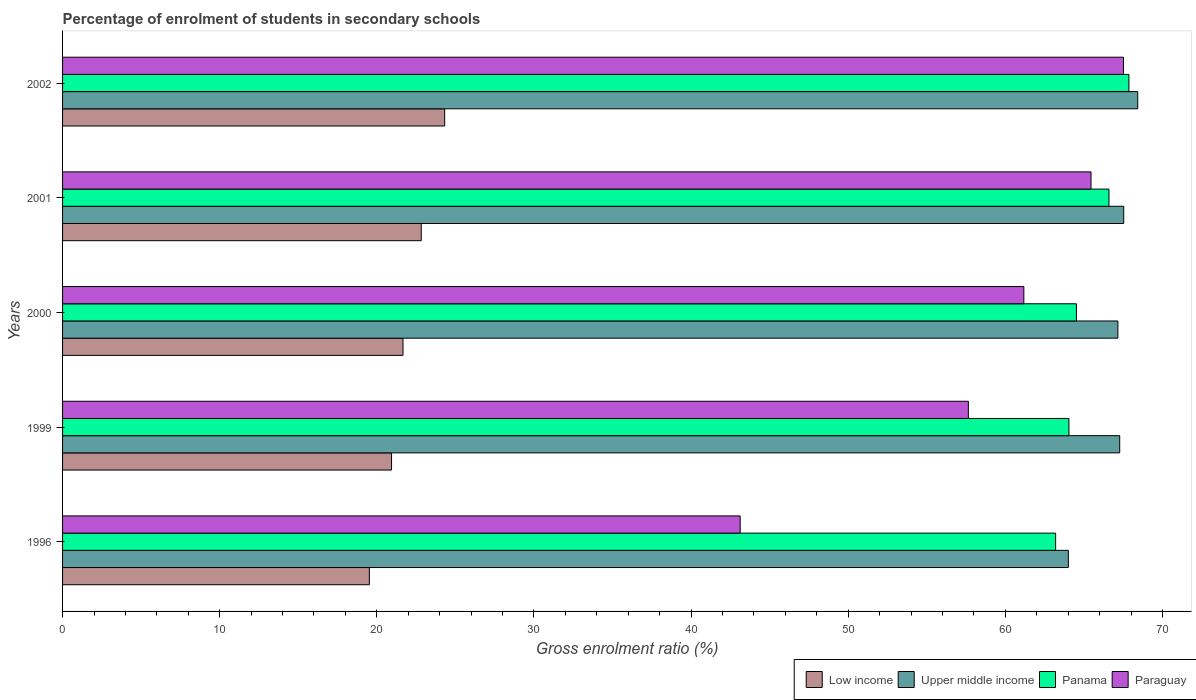How many different coloured bars are there?
Give a very brief answer. 4. Are the number of bars per tick equal to the number of legend labels?
Provide a succinct answer. Yes. How many bars are there on the 1st tick from the top?
Provide a short and direct response. 4. What is the percentage of students enrolled in secondary schools in Paraguay in 2001?
Ensure brevity in your answer.  65.45. Across all years, what is the maximum percentage of students enrolled in secondary schools in Panama?
Offer a terse response. 67.86. Across all years, what is the minimum percentage of students enrolled in secondary schools in Panama?
Offer a very short reply. 63.2. In which year was the percentage of students enrolled in secondary schools in Paraguay maximum?
Your response must be concise. 2002. What is the total percentage of students enrolled in secondary schools in Upper middle income in the graph?
Offer a very short reply. 334.39. What is the difference between the percentage of students enrolled in secondary schools in Upper middle income in 1999 and that in 2001?
Provide a succinct answer. -0.26. What is the difference between the percentage of students enrolled in secondary schools in Low income in 1996 and the percentage of students enrolled in secondary schools in Panama in 2000?
Provide a succinct answer. -45. What is the average percentage of students enrolled in secondary schools in Panama per year?
Your answer should be compact. 65.24. In the year 2001, what is the difference between the percentage of students enrolled in secondary schools in Panama and percentage of students enrolled in secondary schools in Upper middle income?
Make the answer very short. -0.94. In how many years, is the percentage of students enrolled in secondary schools in Paraguay greater than 38 %?
Your answer should be very brief. 5. What is the ratio of the percentage of students enrolled in secondary schools in Low income in 1999 to that in 2001?
Keep it short and to the point. 0.92. Is the difference between the percentage of students enrolled in secondary schools in Panama in 2001 and 2002 greater than the difference between the percentage of students enrolled in secondary schools in Upper middle income in 2001 and 2002?
Your answer should be very brief. No. What is the difference between the highest and the second highest percentage of students enrolled in secondary schools in Paraguay?
Provide a succinct answer. 2.07. What is the difference between the highest and the lowest percentage of students enrolled in secondary schools in Paraguay?
Your response must be concise. 24.39. In how many years, is the percentage of students enrolled in secondary schools in Panama greater than the average percentage of students enrolled in secondary schools in Panama taken over all years?
Ensure brevity in your answer.  2. Is the sum of the percentage of students enrolled in secondary schools in Panama in 1996 and 2002 greater than the maximum percentage of students enrolled in secondary schools in Paraguay across all years?
Offer a very short reply. Yes. What does the 2nd bar from the top in 2001 represents?
Provide a succinct answer. Panama. How many bars are there?
Offer a terse response. 20. How many years are there in the graph?
Provide a short and direct response. 5. What is the difference between two consecutive major ticks on the X-axis?
Keep it short and to the point. 10. Does the graph contain grids?
Make the answer very short. No. How many legend labels are there?
Your answer should be compact. 4. How are the legend labels stacked?
Your response must be concise. Horizontal. What is the title of the graph?
Your response must be concise. Percentage of enrolment of students in secondary schools. What is the label or title of the Y-axis?
Make the answer very short. Years. What is the Gross enrolment ratio (%) of Low income in 1996?
Offer a terse response. 19.52. What is the Gross enrolment ratio (%) in Upper middle income in 1996?
Offer a terse response. 64.01. What is the Gross enrolment ratio (%) in Panama in 1996?
Provide a short and direct response. 63.2. What is the Gross enrolment ratio (%) in Paraguay in 1996?
Provide a succinct answer. 43.12. What is the Gross enrolment ratio (%) of Low income in 1999?
Ensure brevity in your answer.  20.94. What is the Gross enrolment ratio (%) of Upper middle income in 1999?
Offer a terse response. 67.27. What is the Gross enrolment ratio (%) of Panama in 1999?
Offer a terse response. 64.04. What is the Gross enrolment ratio (%) of Paraguay in 1999?
Ensure brevity in your answer.  57.64. What is the Gross enrolment ratio (%) in Low income in 2000?
Offer a very short reply. 21.66. What is the Gross enrolment ratio (%) in Upper middle income in 2000?
Offer a terse response. 67.16. What is the Gross enrolment ratio (%) in Panama in 2000?
Offer a terse response. 64.52. What is the Gross enrolment ratio (%) of Paraguay in 2000?
Your answer should be very brief. 61.17. What is the Gross enrolment ratio (%) of Low income in 2001?
Your answer should be very brief. 22.83. What is the Gross enrolment ratio (%) of Upper middle income in 2001?
Your response must be concise. 67.53. What is the Gross enrolment ratio (%) in Panama in 2001?
Provide a succinct answer. 66.59. What is the Gross enrolment ratio (%) of Paraguay in 2001?
Provide a succinct answer. 65.45. What is the Gross enrolment ratio (%) in Low income in 2002?
Your answer should be compact. 24.32. What is the Gross enrolment ratio (%) of Upper middle income in 2002?
Keep it short and to the point. 68.42. What is the Gross enrolment ratio (%) of Panama in 2002?
Offer a terse response. 67.86. What is the Gross enrolment ratio (%) in Paraguay in 2002?
Keep it short and to the point. 67.51. Across all years, what is the maximum Gross enrolment ratio (%) of Low income?
Ensure brevity in your answer.  24.32. Across all years, what is the maximum Gross enrolment ratio (%) in Upper middle income?
Provide a short and direct response. 68.42. Across all years, what is the maximum Gross enrolment ratio (%) in Panama?
Keep it short and to the point. 67.86. Across all years, what is the maximum Gross enrolment ratio (%) in Paraguay?
Provide a short and direct response. 67.51. Across all years, what is the minimum Gross enrolment ratio (%) in Low income?
Your answer should be compact. 19.52. Across all years, what is the minimum Gross enrolment ratio (%) of Upper middle income?
Your answer should be compact. 64.01. Across all years, what is the minimum Gross enrolment ratio (%) in Panama?
Give a very brief answer. 63.2. Across all years, what is the minimum Gross enrolment ratio (%) in Paraguay?
Provide a succinct answer. 43.12. What is the total Gross enrolment ratio (%) in Low income in the graph?
Keep it short and to the point. 109.27. What is the total Gross enrolment ratio (%) of Upper middle income in the graph?
Provide a succinct answer. 334.39. What is the total Gross enrolment ratio (%) in Panama in the graph?
Offer a very short reply. 326.21. What is the total Gross enrolment ratio (%) of Paraguay in the graph?
Your response must be concise. 294.9. What is the difference between the Gross enrolment ratio (%) of Low income in 1996 and that in 1999?
Ensure brevity in your answer.  -1.41. What is the difference between the Gross enrolment ratio (%) in Upper middle income in 1996 and that in 1999?
Make the answer very short. -3.27. What is the difference between the Gross enrolment ratio (%) in Panama in 1996 and that in 1999?
Make the answer very short. -0.85. What is the difference between the Gross enrolment ratio (%) of Paraguay in 1996 and that in 1999?
Offer a terse response. -14.52. What is the difference between the Gross enrolment ratio (%) in Low income in 1996 and that in 2000?
Provide a succinct answer. -2.14. What is the difference between the Gross enrolment ratio (%) in Upper middle income in 1996 and that in 2000?
Give a very brief answer. -3.15. What is the difference between the Gross enrolment ratio (%) in Panama in 1996 and that in 2000?
Provide a succinct answer. -1.33. What is the difference between the Gross enrolment ratio (%) of Paraguay in 1996 and that in 2000?
Provide a succinct answer. -18.05. What is the difference between the Gross enrolment ratio (%) of Low income in 1996 and that in 2001?
Provide a succinct answer. -3.3. What is the difference between the Gross enrolment ratio (%) of Upper middle income in 1996 and that in 2001?
Offer a terse response. -3.52. What is the difference between the Gross enrolment ratio (%) in Panama in 1996 and that in 2001?
Make the answer very short. -3.39. What is the difference between the Gross enrolment ratio (%) in Paraguay in 1996 and that in 2001?
Your response must be concise. -22.33. What is the difference between the Gross enrolment ratio (%) in Low income in 1996 and that in 2002?
Your answer should be compact. -4.79. What is the difference between the Gross enrolment ratio (%) in Upper middle income in 1996 and that in 2002?
Provide a succinct answer. -4.41. What is the difference between the Gross enrolment ratio (%) of Panama in 1996 and that in 2002?
Offer a very short reply. -4.66. What is the difference between the Gross enrolment ratio (%) in Paraguay in 1996 and that in 2002?
Offer a terse response. -24.39. What is the difference between the Gross enrolment ratio (%) in Low income in 1999 and that in 2000?
Provide a succinct answer. -0.73. What is the difference between the Gross enrolment ratio (%) of Upper middle income in 1999 and that in 2000?
Ensure brevity in your answer.  0.12. What is the difference between the Gross enrolment ratio (%) of Panama in 1999 and that in 2000?
Provide a succinct answer. -0.48. What is the difference between the Gross enrolment ratio (%) in Paraguay in 1999 and that in 2000?
Your answer should be compact. -3.53. What is the difference between the Gross enrolment ratio (%) of Low income in 1999 and that in 2001?
Offer a very short reply. -1.89. What is the difference between the Gross enrolment ratio (%) in Upper middle income in 1999 and that in 2001?
Make the answer very short. -0.26. What is the difference between the Gross enrolment ratio (%) of Panama in 1999 and that in 2001?
Offer a terse response. -2.55. What is the difference between the Gross enrolment ratio (%) in Paraguay in 1999 and that in 2001?
Provide a short and direct response. -7.81. What is the difference between the Gross enrolment ratio (%) of Low income in 1999 and that in 2002?
Your response must be concise. -3.38. What is the difference between the Gross enrolment ratio (%) in Upper middle income in 1999 and that in 2002?
Your answer should be compact. -1.15. What is the difference between the Gross enrolment ratio (%) in Panama in 1999 and that in 2002?
Your response must be concise. -3.82. What is the difference between the Gross enrolment ratio (%) of Paraguay in 1999 and that in 2002?
Your answer should be very brief. -9.87. What is the difference between the Gross enrolment ratio (%) of Low income in 2000 and that in 2001?
Give a very brief answer. -1.16. What is the difference between the Gross enrolment ratio (%) of Upper middle income in 2000 and that in 2001?
Offer a terse response. -0.37. What is the difference between the Gross enrolment ratio (%) in Panama in 2000 and that in 2001?
Provide a short and direct response. -2.07. What is the difference between the Gross enrolment ratio (%) in Paraguay in 2000 and that in 2001?
Make the answer very short. -4.28. What is the difference between the Gross enrolment ratio (%) in Low income in 2000 and that in 2002?
Make the answer very short. -2.65. What is the difference between the Gross enrolment ratio (%) of Upper middle income in 2000 and that in 2002?
Offer a very short reply. -1.26. What is the difference between the Gross enrolment ratio (%) in Panama in 2000 and that in 2002?
Provide a succinct answer. -3.34. What is the difference between the Gross enrolment ratio (%) of Paraguay in 2000 and that in 2002?
Keep it short and to the point. -6.34. What is the difference between the Gross enrolment ratio (%) of Low income in 2001 and that in 2002?
Make the answer very short. -1.49. What is the difference between the Gross enrolment ratio (%) in Upper middle income in 2001 and that in 2002?
Provide a short and direct response. -0.89. What is the difference between the Gross enrolment ratio (%) in Panama in 2001 and that in 2002?
Your response must be concise. -1.27. What is the difference between the Gross enrolment ratio (%) in Paraguay in 2001 and that in 2002?
Your answer should be very brief. -2.07. What is the difference between the Gross enrolment ratio (%) of Low income in 1996 and the Gross enrolment ratio (%) of Upper middle income in 1999?
Keep it short and to the point. -47.75. What is the difference between the Gross enrolment ratio (%) in Low income in 1996 and the Gross enrolment ratio (%) in Panama in 1999?
Make the answer very short. -44.52. What is the difference between the Gross enrolment ratio (%) in Low income in 1996 and the Gross enrolment ratio (%) in Paraguay in 1999?
Your answer should be compact. -38.12. What is the difference between the Gross enrolment ratio (%) of Upper middle income in 1996 and the Gross enrolment ratio (%) of Panama in 1999?
Your answer should be very brief. -0.04. What is the difference between the Gross enrolment ratio (%) of Upper middle income in 1996 and the Gross enrolment ratio (%) of Paraguay in 1999?
Ensure brevity in your answer.  6.36. What is the difference between the Gross enrolment ratio (%) in Panama in 1996 and the Gross enrolment ratio (%) in Paraguay in 1999?
Your answer should be compact. 5.55. What is the difference between the Gross enrolment ratio (%) in Low income in 1996 and the Gross enrolment ratio (%) in Upper middle income in 2000?
Provide a short and direct response. -47.64. What is the difference between the Gross enrolment ratio (%) of Low income in 1996 and the Gross enrolment ratio (%) of Panama in 2000?
Ensure brevity in your answer.  -45. What is the difference between the Gross enrolment ratio (%) of Low income in 1996 and the Gross enrolment ratio (%) of Paraguay in 2000?
Your answer should be compact. -41.65. What is the difference between the Gross enrolment ratio (%) of Upper middle income in 1996 and the Gross enrolment ratio (%) of Panama in 2000?
Provide a succinct answer. -0.52. What is the difference between the Gross enrolment ratio (%) of Upper middle income in 1996 and the Gross enrolment ratio (%) of Paraguay in 2000?
Your answer should be very brief. 2.83. What is the difference between the Gross enrolment ratio (%) of Panama in 1996 and the Gross enrolment ratio (%) of Paraguay in 2000?
Make the answer very short. 2.02. What is the difference between the Gross enrolment ratio (%) in Low income in 1996 and the Gross enrolment ratio (%) in Upper middle income in 2001?
Keep it short and to the point. -48.01. What is the difference between the Gross enrolment ratio (%) in Low income in 1996 and the Gross enrolment ratio (%) in Panama in 2001?
Provide a succinct answer. -47.07. What is the difference between the Gross enrolment ratio (%) in Low income in 1996 and the Gross enrolment ratio (%) in Paraguay in 2001?
Offer a very short reply. -45.93. What is the difference between the Gross enrolment ratio (%) of Upper middle income in 1996 and the Gross enrolment ratio (%) of Panama in 2001?
Your answer should be compact. -2.58. What is the difference between the Gross enrolment ratio (%) of Upper middle income in 1996 and the Gross enrolment ratio (%) of Paraguay in 2001?
Give a very brief answer. -1.44. What is the difference between the Gross enrolment ratio (%) in Panama in 1996 and the Gross enrolment ratio (%) in Paraguay in 2001?
Offer a very short reply. -2.25. What is the difference between the Gross enrolment ratio (%) in Low income in 1996 and the Gross enrolment ratio (%) in Upper middle income in 2002?
Your answer should be compact. -48.9. What is the difference between the Gross enrolment ratio (%) of Low income in 1996 and the Gross enrolment ratio (%) of Panama in 2002?
Your answer should be very brief. -48.34. What is the difference between the Gross enrolment ratio (%) in Low income in 1996 and the Gross enrolment ratio (%) in Paraguay in 2002?
Give a very brief answer. -47.99. What is the difference between the Gross enrolment ratio (%) of Upper middle income in 1996 and the Gross enrolment ratio (%) of Panama in 2002?
Make the answer very short. -3.85. What is the difference between the Gross enrolment ratio (%) in Upper middle income in 1996 and the Gross enrolment ratio (%) in Paraguay in 2002?
Give a very brief answer. -3.51. What is the difference between the Gross enrolment ratio (%) of Panama in 1996 and the Gross enrolment ratio (%) of Paraguay in 2002?
Keep it short and to the point. -4.32. What is the difference between the Gross enrolment ratio (%) in Low income in 1999 and the Gross enrolment ratio (%) in Upper middle income in 2000?
Ensure brevity in your answer.  -46.22. What is the difference between the Gross enrolment ratio (%) of Low income in 1999 and the Gross enrolment ratio (%) of Panama in 2000?
Provide a succinct answer. -43.59. What is the difference between the Gross enrolment ratio (%) in Low income in 1999 and the Gross enrolment ratio (%) in Paraguay in 2000?
Offer a very short reply. -40.24. What is the difference between the Gross enrolment ratio (%) of Upper middle income in 1999 and the Gross enrolment ratio (%) of Panama in 2000?
Your answer should be compact. 2.75. What is the difference between the Gross enrolment ratio (%) of Upper middle income in 1999 and the Gross enrolment ratio (%) of Paraguay in 2000?
Your answer should be very brief. 6.1. What is the difference between the Gross enrolment ratio (%) of Panama in 1999 and the Gross enrolment ratio (%) of Paraguay in 2000?
Give a very brief answer. 2.87. What is the difference between the Gross enrolment ratio (%) in Low income in 1999 and the Gross enrolment ratio (%) in Upper middle income in 2001?
Ensure brevity in your answer.  -46.59. What is the difference between the Gross enrolment ratio (%) in Low income in 1999 and the Gross enrolment ratio (%) in Panama in 2001?
Provide a short and direct response. -45.65. What is the difference between the Gross enrolment ratio (%) in Low income in 1999 and the Gross enrolment ratio (%) in Paraguay in 2001?
Make the answer very short. -44.51. What is the difference between the Gross enrolment ratio (%) in Upper middle income in 1999 and the Gross enrolment ratio (%) in Panama in 2001?
Make the answer very short. 0.68. What is the difference between the Gross enrolment ratio (%) in Upper middle income in 1999 and the Gross enrolment ratio (%) in Paraguay in 2001?
Your response must be concise. 1.83. What is the difference between the Gross enrolment ratio (%) of Panama in 1999 and the Gross enrolment ratio (%) of Paraguay in 2001?
Give a very brief answer. -1.41. What is the difference between the Gross enrolment ratio (%) of Low income in 1999 and the Gross enrolment ratio (%) of Upper middle income in 2002?
Make the answer very short. -47.49. What is the difference between the Gross enrolment ratio (%) in Low income in 1999 and the Gross enrolment ratio (%) in Panama in 2002?
Offer a very short reply. -46.92. What is the difference between the Gross enrolment ratio (%) of Low income in 1999 and the Gross enrolment ratio (%) of Paraguay in 2002?
Offer a very short reply. -46.58. What is the difference between the Gross enrolment ratio (%) of Upper middle income in 1999 and the Gross enrolment ratio (%) of Panama in 2002?
Offer a terse response. -0.59. What is the difference between the Gross enrolment ratio (%) of Upper middle income in 1999 and the Gross enrolment ratio (%) of Paraguay in 2002?
Your response must be concise. -0.24. What is the difference between the Gross enrolment ratio (%) of Panama in 1999 and the Gross enrolment ratio (%) of Paraguay in 2002?
Ensure brevity in your answer.  -3.47. What is the difference between the Gross enrolment ratio (%) in Low income in 2000 and the Gross enrolment ratio (%) in Upper middle income in 2001?
Keep it short and to the point. -45.87. What is the difference between the Gross enrolment ratio (%) of Low income in 2000 and the Gross enrolment ratio (%) of Panama in 2001?
Your answer should be very brief. -44.93. What is the difference between the Gross enrolment ratio (%) in Low income in 2000 and the Gross enrolment ratio (%) in Paraguay in 2001?
Give a very brief answer. -43.78. What is the difference between the Gross enrolment ratio (%) in Upper middle income in 2000 and the Gross enrolment ratio (%) in Panama in 2001?
Provide a short and direct response. 0.57. What is the difference between the Gross enrolment ratio (%) of Upper middle income in 2000 and the Gross enrolment ratio (%) of Paraguay in 2001?
Your answer should be compact. 1.71. What is the difference between the Gross enrolment ratio (%) of Panama in 2000 and the Gross enrolment ratio (%) of Paraguay in 2001?
Offer a terse response. -0.93. What is the difference between the Gross enrolment ratio (%) of Low income in 2000 and the Gross enrolment ratio (%) of Upper middle income in 2002?
Ensure brevity in your answer.  -46.76. What is the difference between the Gross enrolment ratio (%) of Low income in 2000 and the Gross enrolment ratio (%) of Panama in 2002?
Keep it short and to the point. -46.2. What is the difference between the Gross enrolment ratio (%) in Low income in 2000 and the Gross enrolment ratio (%) in Paraguay in 2002?
Provide a succinct answer. -45.85. What is the difference between the Gross enrolment ratio (%) in Upper middle income in 2000 and the Gross enrolment ratio (%) in Panama in 2002?
Offer a terse response. -0.7. What is the difference between the Gross enrolment ratio (%) in Upper middle income in 2000 and the Gross enrolment ratio (%) in Paraguay in 2002?
Give a very brief answer. -0.36. What is the difference between the Gross enrolment ratio (%) in Panama in 2000 and the Gross enrolment ratio (%) in Paraguay in 2002?
Your answer should be very brief. -2.99. What is the difference between the Gross enrolment ratio (%) of Low income in 2001 and the Gross enrolment ratio (%) of Upper middle income in 2002?
Make the answer very short. -45.6. What is the difference between the Gross enrolment ratio (%) in Low income in 2001 and the Gross enrolment ratio (%) in Panama in 2002?
Keep it short and to the point. -45.03. What is the difference between the Gross enrolment ratio (%) in Low income in 2001 and the Gross enrolment ratio (%) in Paraguay in 2002?
Your answer should be compact. -44.69. What is the difference between the Gross enrolment ratio (%) of Upper middle income in 2001 and the Gross enrolment ratio (%) of Panama in 2002?
Provide a succinct answer. -0.33. What is the difference between the Gross enrolment ratio (%) of Upper middle income in 2001 and the Gross enrolment ratio (%) of Paraguay in 2002?
Make the answer very short. 0.02. What is the difference between the Gross enrolment ratio (%) of Panama in 2001 and the Gross enrolment ratio (%) of Paraguay in 2002?
Your response must be concise. -0.92. What is the average Gross enrolment ratio (%) of Low income per year?
Offer a terse response. 21.85. What is the average Gross enrolment ratio (%) in Upper middle income per year?
Ensure brevity in your answer.  66.88. What is the average Gross enrolment ratio (%) in Panama per year?
Your response must be concise. 65.24. What is the average Gross enrolment ratio (%) of Paraguay per year?
Provide a short and direct response. 58.98. In the year 1996, what is the difference between the Gross enrolment ratio (%) in Low income and Gross enrolment ratio (%) in Upper middle income?
Provide a short and direct response. -44.48. In the year 1996, what is the difference between the Gross enrolment ratio (%) of Low income and Gross enrolment ratio (%) of Panama?
Offer a very short reply. -43.67. In the year 1996, what is the difference between the Gross enrolment ratio (%) in Low income and Gross enrolment ratio (%) in Paraguay?
Provide a succinct answer. -23.6. In the year 1996, what is the difference between the Gross enrolment ratio (%) in Upper middle income and Gross enrolment ratio (%) in Panama?
Give a very brief answer. 0.81. In the year 1996, what is the difference between the Gross enrolment ratio (%) in Upper middle income and Gross enrolment ratio (%) in Paraguay?
Give a very brief answer. 20.89. In the year 1996, what is the difference between the Gross enrolment ratio (%) of Panama and Gross enrolment ratio (%) of Paraguay?
Your answer should be compact. 20.07. In the year 1999, what is the difference between the Gross enrolment ratio (%) in Low income and Gross enrolment ratio (%) in Upper middle income?
Your answer should be very brief. -46.34. In the year 1999, what is the difference between the Gross enrolment ratio (%) in Low income and Gross enrolment ratio (%) in Panama?
Offer a terse response. -43.11. In the year 1999, what is the difference between the Gross enrolment ratio (%) of Low income and Gross enrolment ratio (%) of Paraguay?
Give a very brief answer. -36.71. In the year 1999, what is the difference between the Gross enrolment ratio (%) of Upper middle income and Gross enrolment ratio (%) of Panama?
Give a very brief answer. 3.23. In the year 1999, what is the difference between the Gross enrolment ratio (%) in Upper middle income and Gross enrolment ratio (%) in Paraguay?
Ensure brevity in your answer.  9.63. In the year 1999, what is the difference between the Gross enrolment ratio (%) of Panama and Gross enrolment ratio (%) of Paraguay?
Provide a succinct answer. 6.4. In the year 2000, what is the difference between the Gross enrolment ratio (%) of Low income and Gross enrolment ratio (%) of Upper middle income?
Keep it short and to the point. -45.49. In the year 2000, what is the difference between the Gross enrolment ratio (%) of Low income and Gross enrolment ratio (%) of Panama?
Your response must be concise. -42.86. In the year 2000, what is the difference between the Gross enrolment ratio (%) of Low income and Gross enrolment ratio (%) of Paraguay?
Keep it short and to the point. -39.51. In the year 2000, what is the difference between the Gross enrolment ratio (%) in Upper middle income and Gross enrolment ratio (%) in Panama?
Ensure brevity in your answer.  2.64. In the year 2000, what is the difference between the Gross enrolment ratio (%) in Upper middle income and Gross enrolment ratio (%) in Paraguay?
Ensure brevity in your answer.  5.98. In the year 2000, what is the difference between the Gross enrolment ratio (%) in Panama and Gross enrolment ratio (%) in Paraguay?
Make the answer very short. 3.35. In the year 2001, what is the difference between the Gross enrolment ratio (%) of Low income and Gross enrolment ratio (%) of Upper middle income?
Your answer should be very brief. -44.7. In the year 2001, what is the difference between the Gross enrolment ratio (%) of Low income and Gross enrolment ratio (%) of Panama?
Make the answer very short. -43.76. In the year 2001, what is the difference between the Gross enrolment ratio (%) in Low income and Gross enrolment ratio (%) in Paraguay?
Make the answer very short. -42.62. In the year 2001, what is the difference between the Gross enrolment ratio (%) in Upper middle income and Gross enrolment ratio (%) in Panama?
Ensure brevity in your answer.  0.94. In the year 2001, what is the difference between the Gross enrolment ratio (%) in Upper middle income and Gross enrolment ratio (%) in Paraguay?
Your response must be concise. 2.08. In the year 2001, what is the difference between the Gross enrolment ratio (%) in Panama and Gross enrolment ratio (%) in Paraguay?
Ensure brevity in your answer.  1.14. In the year 2002, what is the difference between the Gross enrolment ratio (%) in Low income and Gross enrolment ratio (%) in Upper middle income?
Keep it short and to the point. -44.11. In the year 2002, what is the difference between the Gross enrolment ratio (%) in Low income and Gross enrolment ratio (%) in Panama?
Your answer should be very brief. -43.54. In the year 2002, what is the difference between the Gross enrolment ratio (%) in Low income and Gross enrolment ratio (%) in Paraguay?
Offer a very short reply. -43.2. In the year 2002, what is the difference between the Gross enrolment ratio (%) in Upper middle income and Gross enrolment ratio (%) in Panama?
Your answer should be compact. 0.56. In the year 2002, what is the difference between the Gross enrolment ratio (%) in Upper middle income and Gross enrolment ratio (%) in Paraguay?
Provide a succinct answer. 0.91. In the year 2002, what is the difference between the Gross enrolment ratio (%) of Panama and Gross enrolment ratio (%) of Paraguay?
Provide a succinct answer. 0.35. What is the ratio of the Gross enrolment ratio (%) in Low income in 1996 to that in 1999?
Ensure brevity in your answer.  0.93. What is the ratio of the Gross enrolment ratio (%) in Upper middle income in 1996 to that in 1999?
Provide a succinct answer. 0.95. What is the ratio of the Gross enrolment ratio (%) of Panama in 1996 to that in 1999?
Your answer should be compact. 0.99. What is the ratio of the Gross enrolment ratio (%) in Paraguay in 1996 to that in 1999?
Offer a terse response. 0.75. What is the ratio of the Gross enrolment ratio (%) in Low income in 1996 to that in 2000?
Provide a short and direct response. 0.9. What is the ratio of the Gross enrolment ratio (%) of Upper middle income in 1996 to that in 2000?
Your answer should be compact. 0.95. What is the ratio of the Gross enrolment ratio (%) of Panama in 1996 to that in 2000?
Give a very brief answer. 0.98. What is the ratio of the Gross enrolment ratio (%) of Paraguay in 1996 to that in 2000?
Provide a succinct answer. 0.7. What is the ratio of the Gross enrolment ratio (%) in Low income in 1996 to that in 2001?
Your answer should be very brief. 0.86. What is the ratio of the Gross enrolment ratio (%) in Upper middle income in 1996 to that in 2001?
Your response must be concise. 0.95. What is the ratio of the Gross enrolment ratio (%) in Panama in 1996 to that in 2001?
Ensure brevity in your answer.  0.95. What is the ratio of the Gross enrolment ratio (%) of Paraguay in 1996 to that in 2001?
Give a very brief answer. 0.66. What is the ratio of the Gross enrolment ratio (%) of Low income in 1996 to that in 2002?
Ensure brevity in your answer.  0.8. What is the ratio of the Gross enrolment ratio (%) in Upper middle income in 1996 to that in 2002?
Your answer should be very brief. 0.94. What is the ratio of the Gross enrolment ratio (%) of Panama in 1996 to that in 2002?
Your answer should be compact. 0.93. What is the ratio of the Gross enrolment ratio (%) in Paraguay in 1996 to that in 2002?
Your answer should be compact. 0.64. What is the ratio of the Gross enrolment ratio (%) in Low income in 1999 to that in 2000?
Provide a succinct answer. 0.97. What is the ratio of the Gross enrolment ratio (%) of Upper middle income in 1999 to that in 2000?
Offer a terse response. 1. What is the ratio of the Gross enrolment ratio (%) of Paraguay in 1999 to that in 2000?
Make the answer very short. 0.94. What is the ratio of the Gross enrolment ratio (%) of Low income in 1999 to that in 2001?
Provide a succinct answer. 0.92. What is the ratio of the Gross enrolment ratio (%) of Upper middle income in 1999 to that in 2001?
Keep it short and to the point. 1. What is the ratio of the Gross enrolment ratio (%) of Panama in 1999 to that in 2001?
Give a very brief answer. 0.96. What is the ratio of the Gross enrolment ratio (%) of Paraguay in 1999 to that in 2001?
Give a very brief answer. 0.88. What is the ratio of the Gross enrolment ratio (%) of Low income in 1999 to that in 2002?
Offer a very short reply. 0.86. What is the ratio of the Gross enrolment ratio (%) in Upper middle income in 1999 to that in 2002?
Give a very brief answer. 0.98. What is the ratio of the Gross enrolment ratio (%) in Panama in 1999 to that in 2002?
Make the answer very short. 0.94. What is the ratio of the Gross enrolment ratio (%) of Paraguay in 1999 to that in 2002?
Your response must be concise. 0.85. What is the ratio of the Gross enrolment ratio (%) in Low income in 2000 to that in 2001?
Provide a succinct answer. 0.95. What is the ratio of the Gross enrolment ratio (%) in Panama in 2000 to that in 2001?
Make the answer very short. 0.97. What is the ratio of the Gross enrolment ratio (%) in Paraguay in 2000 to that in 2001?
Your response must be concise. 0.93. What is the ratio of the Gross enrolment ratio (%) in Low income in 2000 to that in 2002?
Your response must be concise. 0.89. What is the ratio of the Gross enrolment ratio (%) of Upper middle income in 2000 to that in 2002?
Make the answer very short. 0.98. What is the ratio of the Gross enrolment ratio (%) of Panama in 2000 to that in 2002?
Make the answer very short. 0.95. What is the ratio of the Gross enrolment ratio (%) in Paraguay in 2000 to that in 2002?
Make the answer very short. 0.91. What is the ratio of the Gross enrolment ratio (%) in Low income in 2001 to that in 2002?
Your response must be concise. 0.94. What is the ratio of the Gross enrolment ratio (%) of Upper middle income in 2001 to that in 2002?
Offer a very short reply. 0.99. What is the ratio of the Gross enrolment ratio (%) of Panama in 2001 to that in 2002?
Your answer should be compact. 0.98. What is the ratio of the Gross enrolment ratio (%) of Paraguay in 2001 to that in 2002?
Provide a succinct answer. 0.97. What is the difference between the highest and the second highest Gross enrolment ratio (%) of Low income?
Give a very brief answer. 1.49. What is the difference between the highest and the second highest Gross enrolment ratio (%) in Upper middle income?
Your answer should be very brief. 0.89. What is the difference between the highest and the second highest Gross enrolment ratio (%) in Panama?
Your answer should be very brief. 1.27. What is the difference between the highest and the second highest Gross enrolment ratio (%) in Paraguay?
Provide a succinct answer. 2.07. What is the difference between the highest and the lowest Gross enrolment ratio (%) in Low income?
Make the answer very short. 4.79. What is the difference between the highest and the lowest Gross enrolment ratio (%) of Upper middle income?
Your answer should be compact. 4.41. What is the difference between the highest and the lowest Gross enrolment ratio (%) of Panama?
Ensure brevity in your answer.  4.66. What is the difference between the highest and the lowest Gross enrolment ratio (%) in Paraguay?
Offer a very short reply. 24.39. 